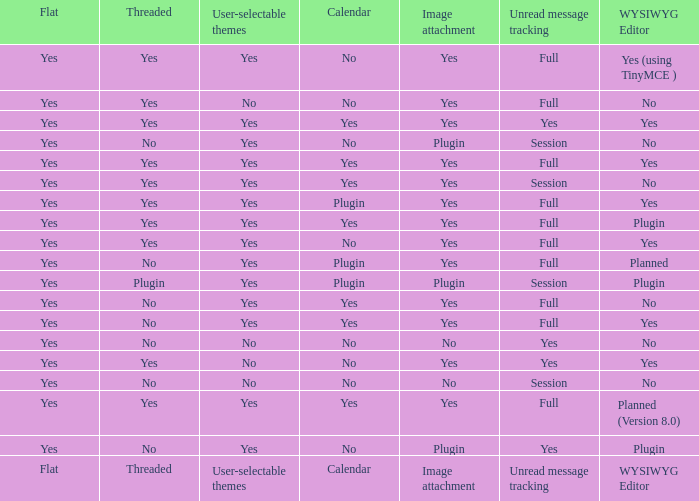Which Image attachment has a Threaded of yes, and a Calendar of yes? Yes, Yes, Yes, Yes, Yes. 